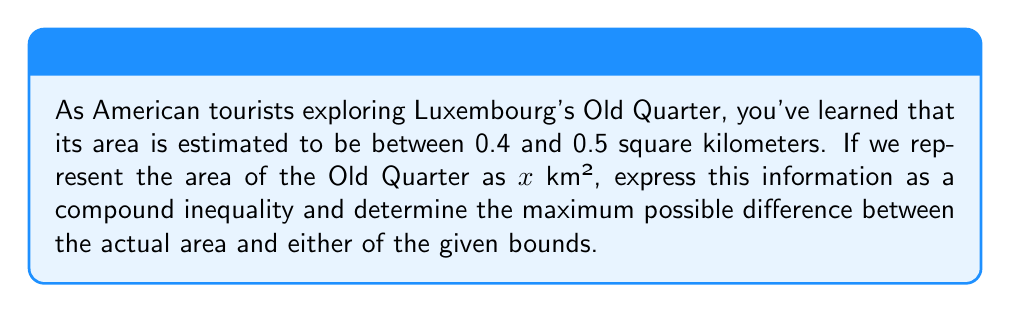What is the answer to this math problem? Let's approach this step-by-step:

1) First, we need to express the given information as a compound inequality:
   
   $$0.4 \leq x \leq 0.5$$

   Where $x$ represents the area of Luxembourg's Old Quarter in square kilometers.

2) To find the maximum possible difference between the actual area and either of the given bounds, we need to consider two scenarios:

   a) The difference between the actual area and the lower bound (0.4 km²)
   b) The difference between the upper bound (0.5 km²) and the actual area

3) The maximum difference will occur when the actual area is at one of the extremes:

   If $x = 0.4$, the difference from the upper bound is: $0.5 - 0.4 = 0.1$ km²
   If $x = 0.5$, the difference from the lower bound is also: $0.5 - 0.4 = 0.1$ km²

4) Therefore, the maximum possible difference is 0.1 km².

5) We can express this mathematically as:

   $$\max(\text{|0.4 - x|, |0.5 - x|}) = 0.1$$

   Where $\max$ denotes the maximum value and $|\cdot|$ denotes the absolute value.
Answer: The maximum possible difference between the actual area of Luxembourg's Old Quarter and either of the given bounds is 0.1 km². 